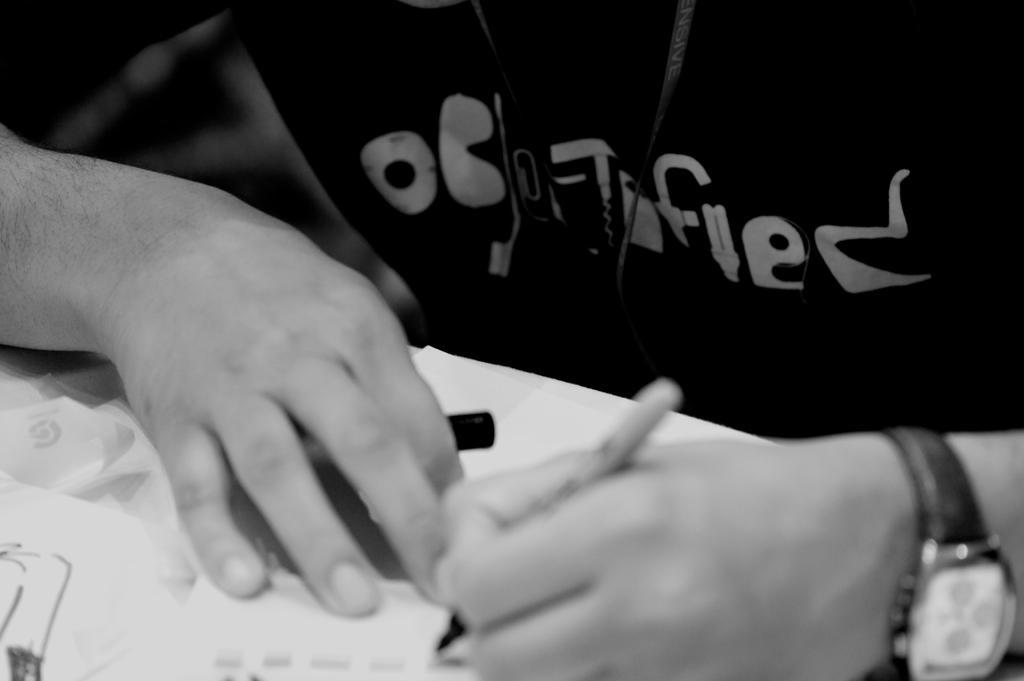Can you describe this image briefly? In this image I can see a person writing something on a paper and this is a black and white image. 